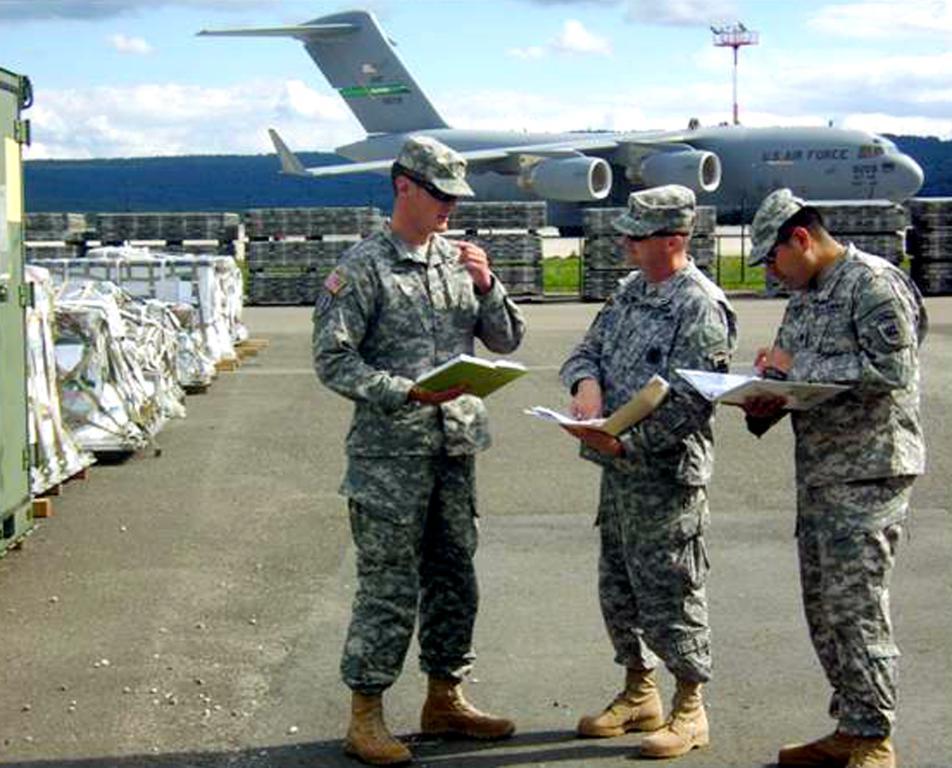In one or two sentences, can you explain what this image depicts? In this image, we can see three persons are standing and holding books. Background we can see an aircraft, few objects, grass, hill, pole and cloudy sky. 